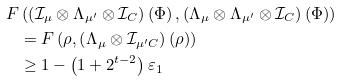<formula> <loc_0><loc_0><loc_500><loc_500>F & \left ( \left ( \mathcal { I } _ { \mu } \otimes \Lambda _ { \mu ^ { \prime } } \otimes \mathcal { I } _ { C } \right ) \left ( \Phi \right ) , \left ( \Lambda _ { \mu } \otimes \Lambda _ { \mu ^ { \prime } } \otimes \mathcal { I } _ { C } \right ) \left ( \Phi \right ) \right ) \\ & = F \left ( \rho , \left ( \Lambda _ { \mu } \otimes \mathcal { I } _ { \mu ^ { \prime } C } \right ) \left ( \rho \right ) \right ) \\ & \geq 1 - \left ( 1 + 2 ^ { t - 2 } \right ) \varepsilon _ { 1 }</formula> 